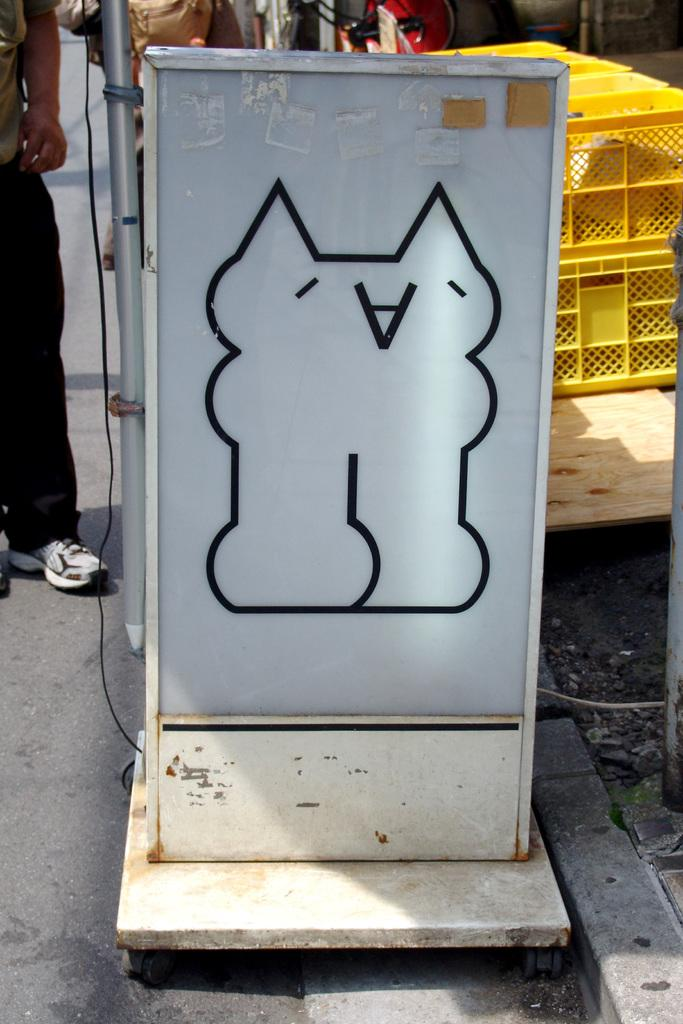What is the main object in the image? There is a white color board poster in the image. What is located behind the board poster? There is a yellow color basket behind the board poster. Is there anyone present in the image? Yes, there is a man standing near the board poster on the left side. What type of copper material is used to make the stocking in the image? There is no copper material or stocking present in the image. Can you describe the gun that the man is holding in the image? There is no gun present in the image; the man is standing near the board poster without any visible objects in his hands. 